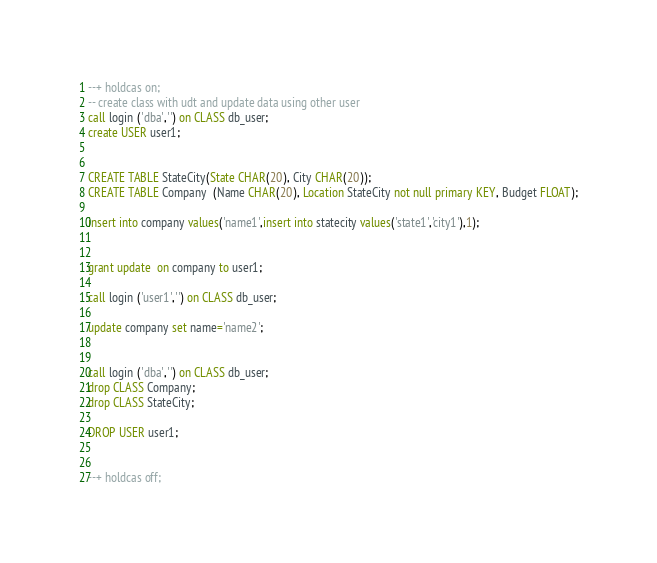<code> <loc_0><loc_0><loc_500><loc_500><_SQL_>--+ holdcas on;
-- create class with udt and update data using other user
call login ('dba','') on CLASS db_user;
create USER user1;


CREATE TABLE StateCity(State CHAR(20), City CHAR(20));
CREATE TABLE Company  (Name CHAR(20), Location StateCity not null primary KEY, Budget FLOAT);

insert into company values('name1',insert into statecity values('state1','city1'),1);


grant update  on company to user1;

call login ('user1','') on CLASS db_user;

update company set name='name2';


call login ('dba','') on CLASS db_user;
drop CLASS Company;
drop CLASS StateCity;

DROP USER user1;


--+ holdcas off;
</code> 